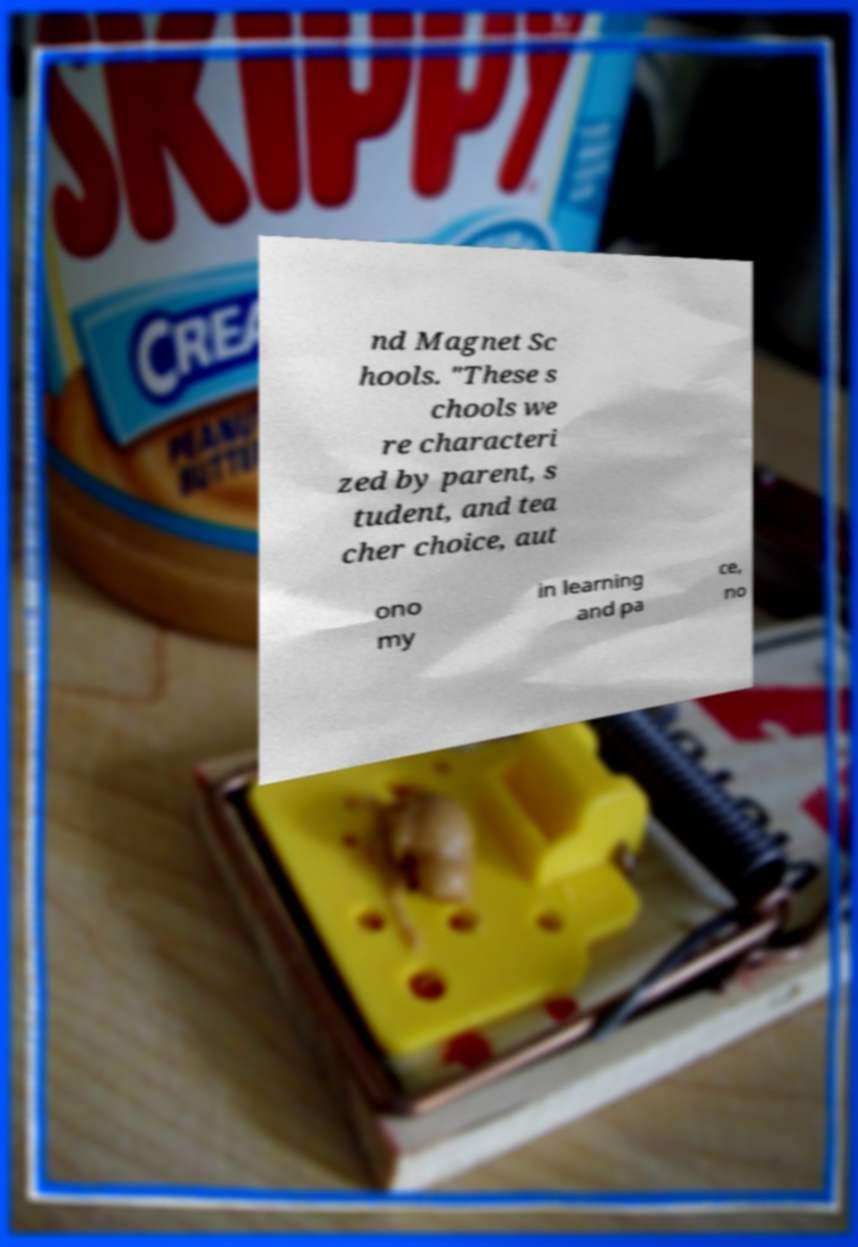Can you accurately transcribe the text from the provided image for me? nd Magnet Sc hools. "These s chools we re characteri zed by parent, s tudent, and tea cher choice, aut ono my in learning and pa ce, no 